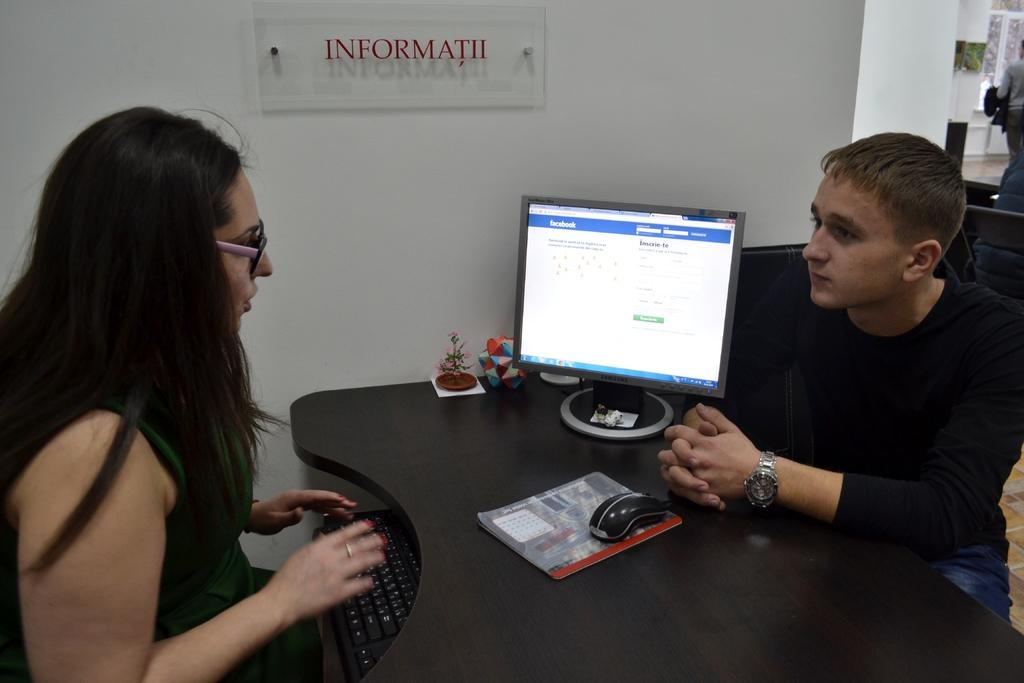<image>
Describe the image concisely. Two people having a conversation in front of a screen that shows Facebook. 